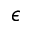<formula> <loc_0><loc_0><loc_500><loc_500>\epsilon</formula> 